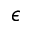<formula> <loc_0><loc_0><loc_500><loc_500>\epsilon</formula> 